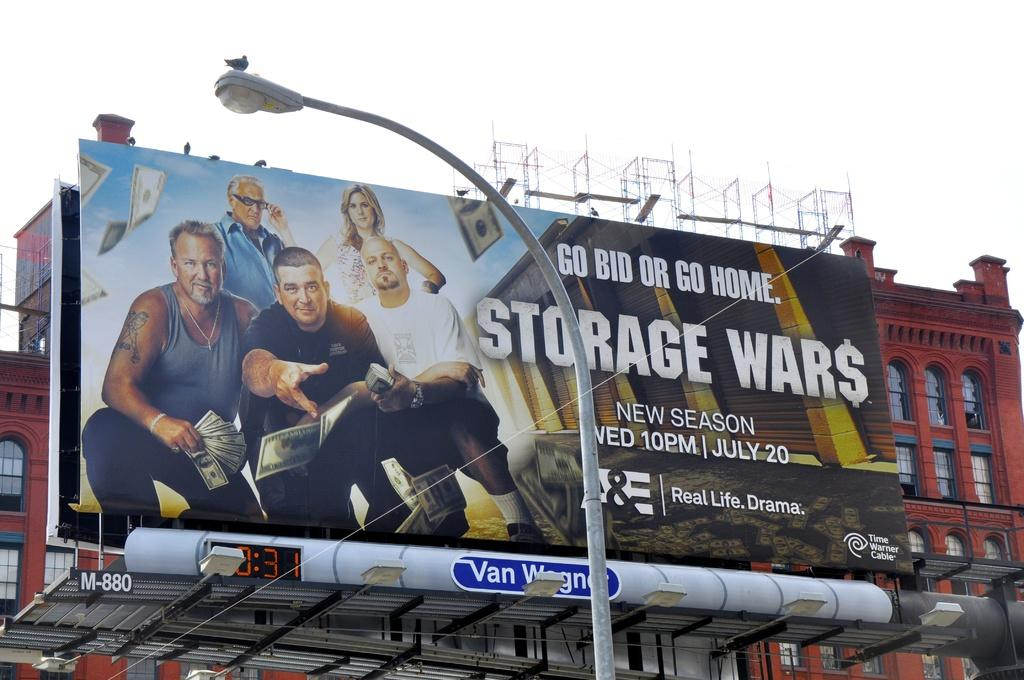<image>
Offer a succinct explanation of the picture presented. a big billboard for Storage War$ that says Go Bid or Go Home 